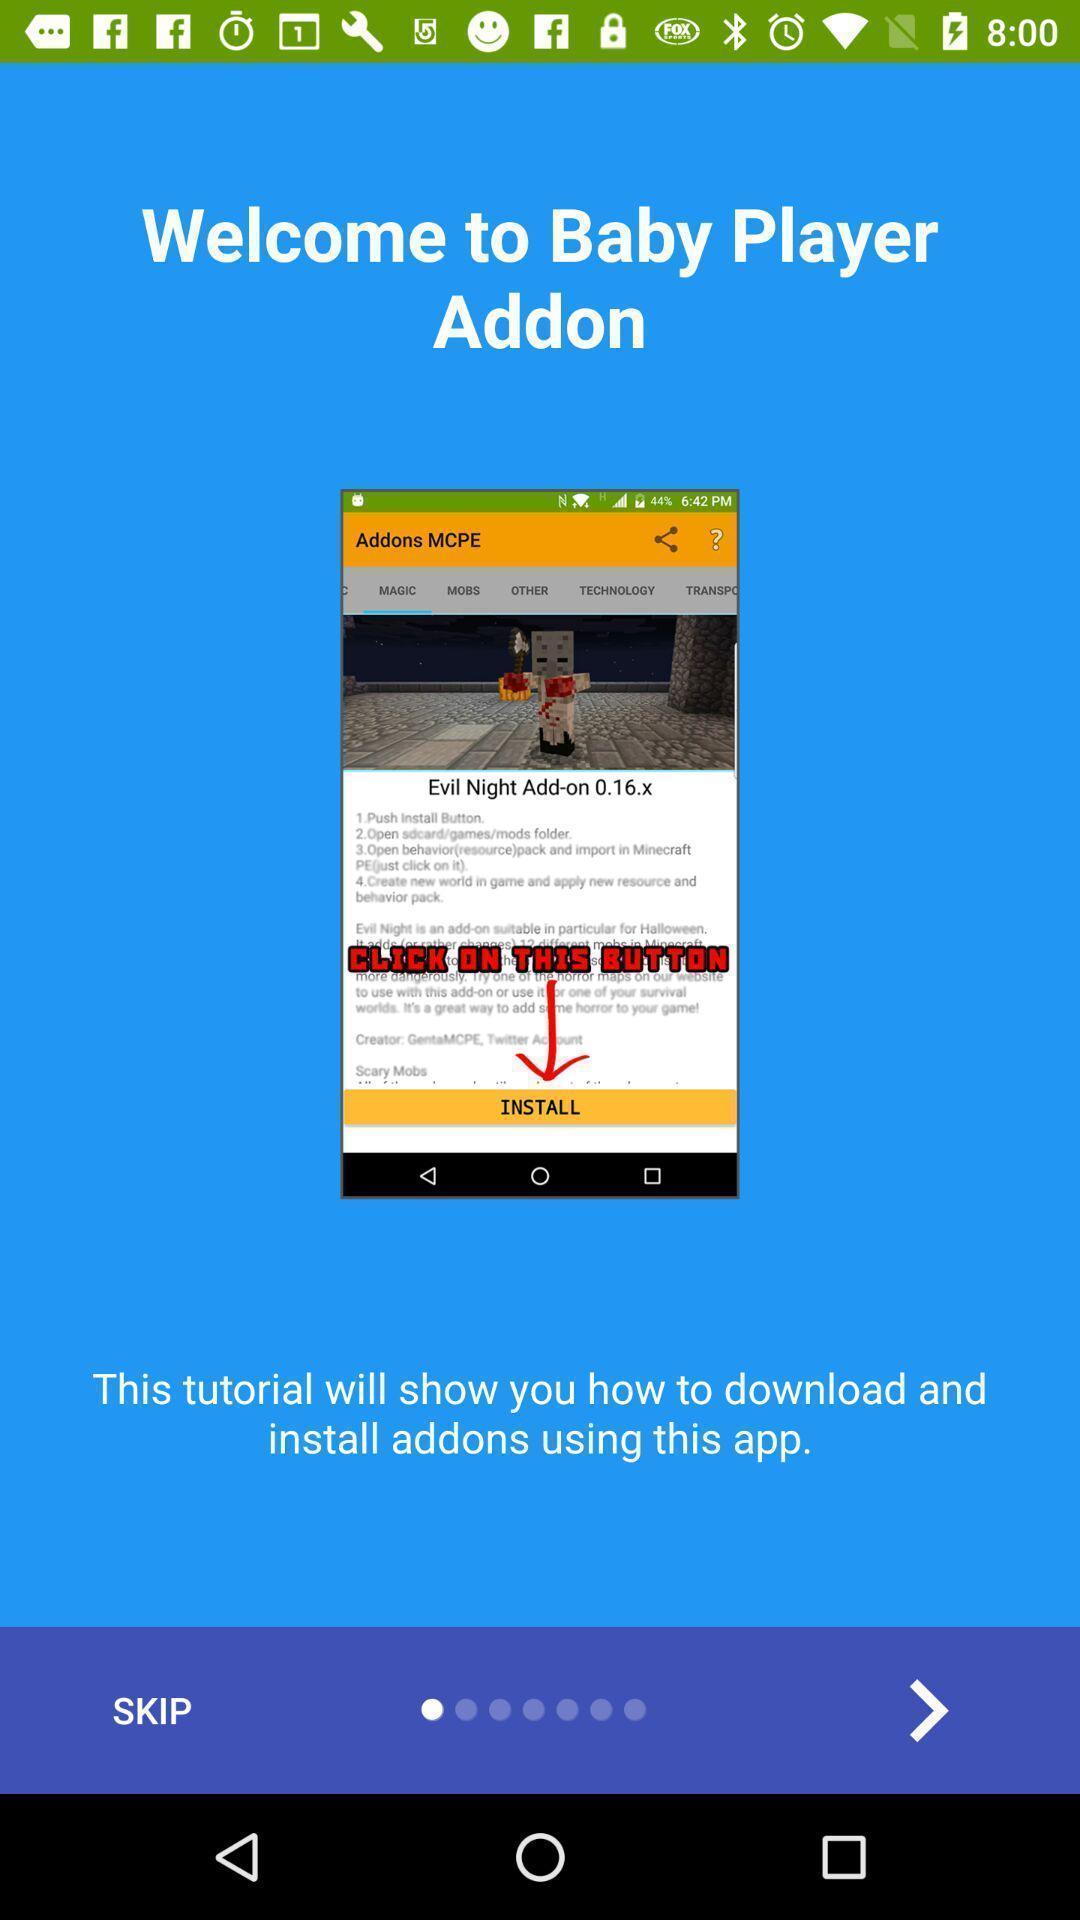Summarize the main components in this picture. Welcome page to the application. 